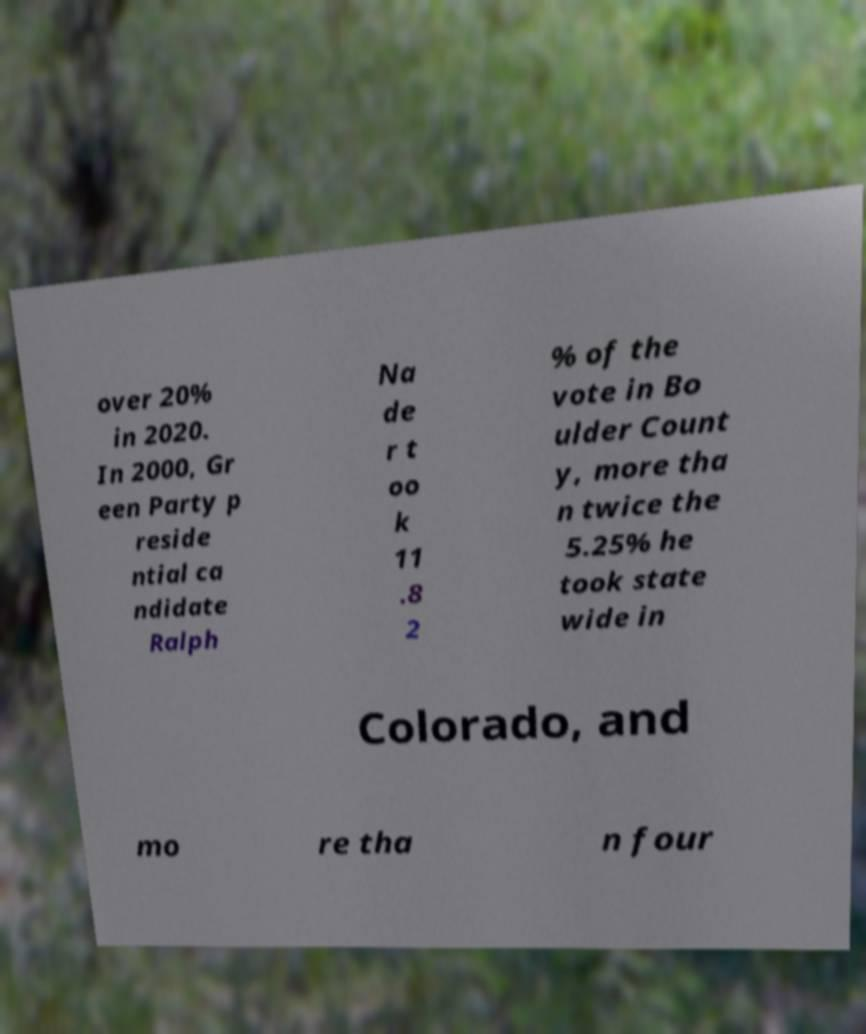Can you read and provide the text displayed in the image?This photo seems to have some interesting text. Can you extract and type it out for me? over 20% in 2020. In 2000, Gr een Party p reside ntial ca ndidate Ralph Na de r t oo k 11 .8 2 % of the vote in Bo ulder Count y, more tha n twice the 5.25% he took state wide in Colorado, and mo re tha n four 